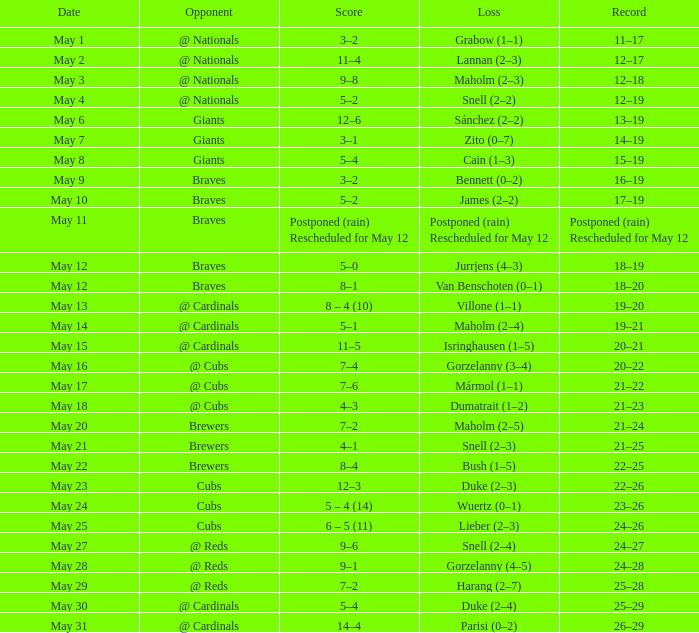Would you be able to parse every entry in this table? {'header': ['Date', 'Opponent', 'Score', 'Loss', 'Record'], 'rows': [['May 1', '@ Nationals', '3–2', 'Grabow (1–1)', '11–17'], ['May 2', '@ Nationals', '11–4', 'Lannan (2–3)', '12–17'], ['May 3', '@ Nationals', '9–8', 'Maholm (2–3)', '12–18'], ['May 4', '@ Nationals', '5–2', 'Snell (2–2)', '12–19'], ['May 6', 'Giants', '12–6', 'Sánchez (2–2)', '13–19'], ['May 7', 'Giants', '3–1', 'Zito (0–7)', '14–19'], ['May 8', 'Giants', '5–4', 'Cain (1–3)', '15–19'], ['May 9', 'Braves', '3–2', 'Bennett (0–2)', '16–19'], ['May 10', 'Braves', '5–2', 'James (2–2)', '17–19'], ['May 11', 'Braves', 'Postponed (rain) Rescheduled for May 12', 'Postponed (rain) Rescheduled for May 12', 'Postponed (rain) Rescheduled for May 12'], ['May 12', 'Braves', '5–0', 'Jurrjens (4–3)', '18–19'], ['May 12', 'Braves', '8–1', 'Van Benschoten (0–1)', '18–20'], ['May 13', '@ Cardinals', '8 – 4 (10)', 'Villone (1–1)', '19–20'], ['May 14', '@ Cardinals', '5–1', 'Maholm (2–4)', '19–21'], ['May 15', '@ Cardinals', '11–5', 'Isringhausen (1–5)', '20–21'], ['May 16', '@ Cubs', '7–4', 'Gorzelanny (3–4)', '20–22'], ['May 17', '@ Cubs', '7–6', 'Mármol (1–1)', '21–22'], ['May 18', '@ Cubs', '4–3', 'Dumatrait (1–2)', '21–23'], ['May 20', 'Brewers', '7–2', 'Maholm (2–5)', '21–24'], ['May 21', 'Brewers', '4–1', 'Snell (2–3)', '21–25'], ['May 22', 'Brewers', '8–4', 'Bush (1–5)', '22–25'], ['May 23', 'Cubs', '12–3', 'Duke (2–3)', '22–26'], ['May 24', 'Cubs', '5 – 4 (14)', 'Wuertz (0–1)', '23–26'], ['May 25', 'Cubs', '6 – 5 (11)', 'Lieber (2–3)', '24–26'], ['May 27', '@ Reds', '9–6', 'Snell (2–4)', '24–27'], ['May 28', '@ Reds', '9–1', 'Gorzelanny (4–5)', '24–28'], ['May 29', '@ Reds', '7–2', 'Harang (2–7)', '25–28'], ['May 30', '@ Cardinals', '5–4', 'Duke (2–4)', '25–29'], ['May 31', '@ Cardinals', '14–4', 'Parisi (0–2)', '26–29']]} Who was the opponent at the game with a score of 7–6? @ Cubs. 